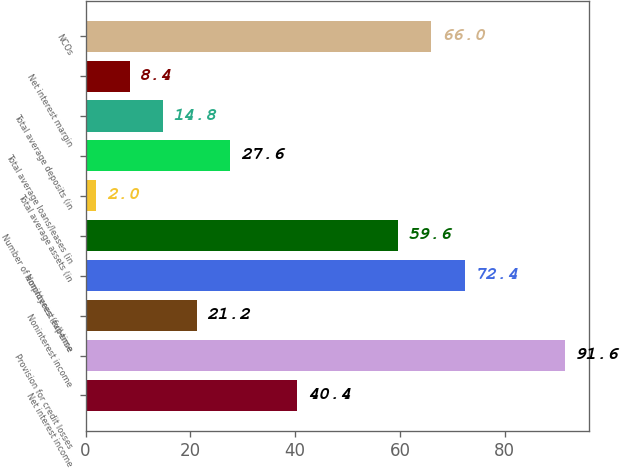Convert chart to OTSL. <chart><loc_0><loc_0><loc_500><loc_500><bar_chart><fcel>Net interest income<fcel>Provision for credit losses<fcel>Noninterest income<fcel>Noninterest expense<fcel>Number of employees (full-time<fcel>Total average assets (in<fcel>Total average loans/leases (in<fcel>Total average deposits (in<fcel>Net interest margin<fcel>NCOs<nl><fcel>40.4<fcel>91.6<fcel>21.2<fcel>72.4<fcel>59.6<fcel>2<fcel>27.6<fcel>14.8<fcel>8.4<fcel>66<nl></chart> 